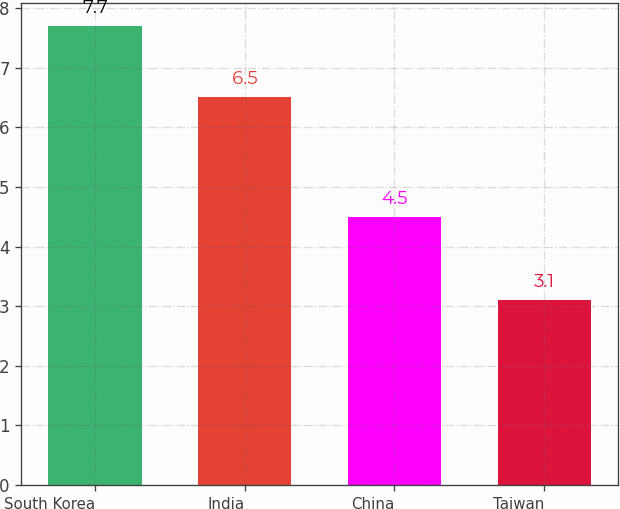Convert chart. <chart><loc_0><loc_0><loc_500><loc_500><bar_chart><fcel>South Korea<fcel>India<fcel>China<fcel>Taiwan<nl><fcel>7.7<fcel>6.5<fcel>4.5<fcel>3.1<nl></chart> 